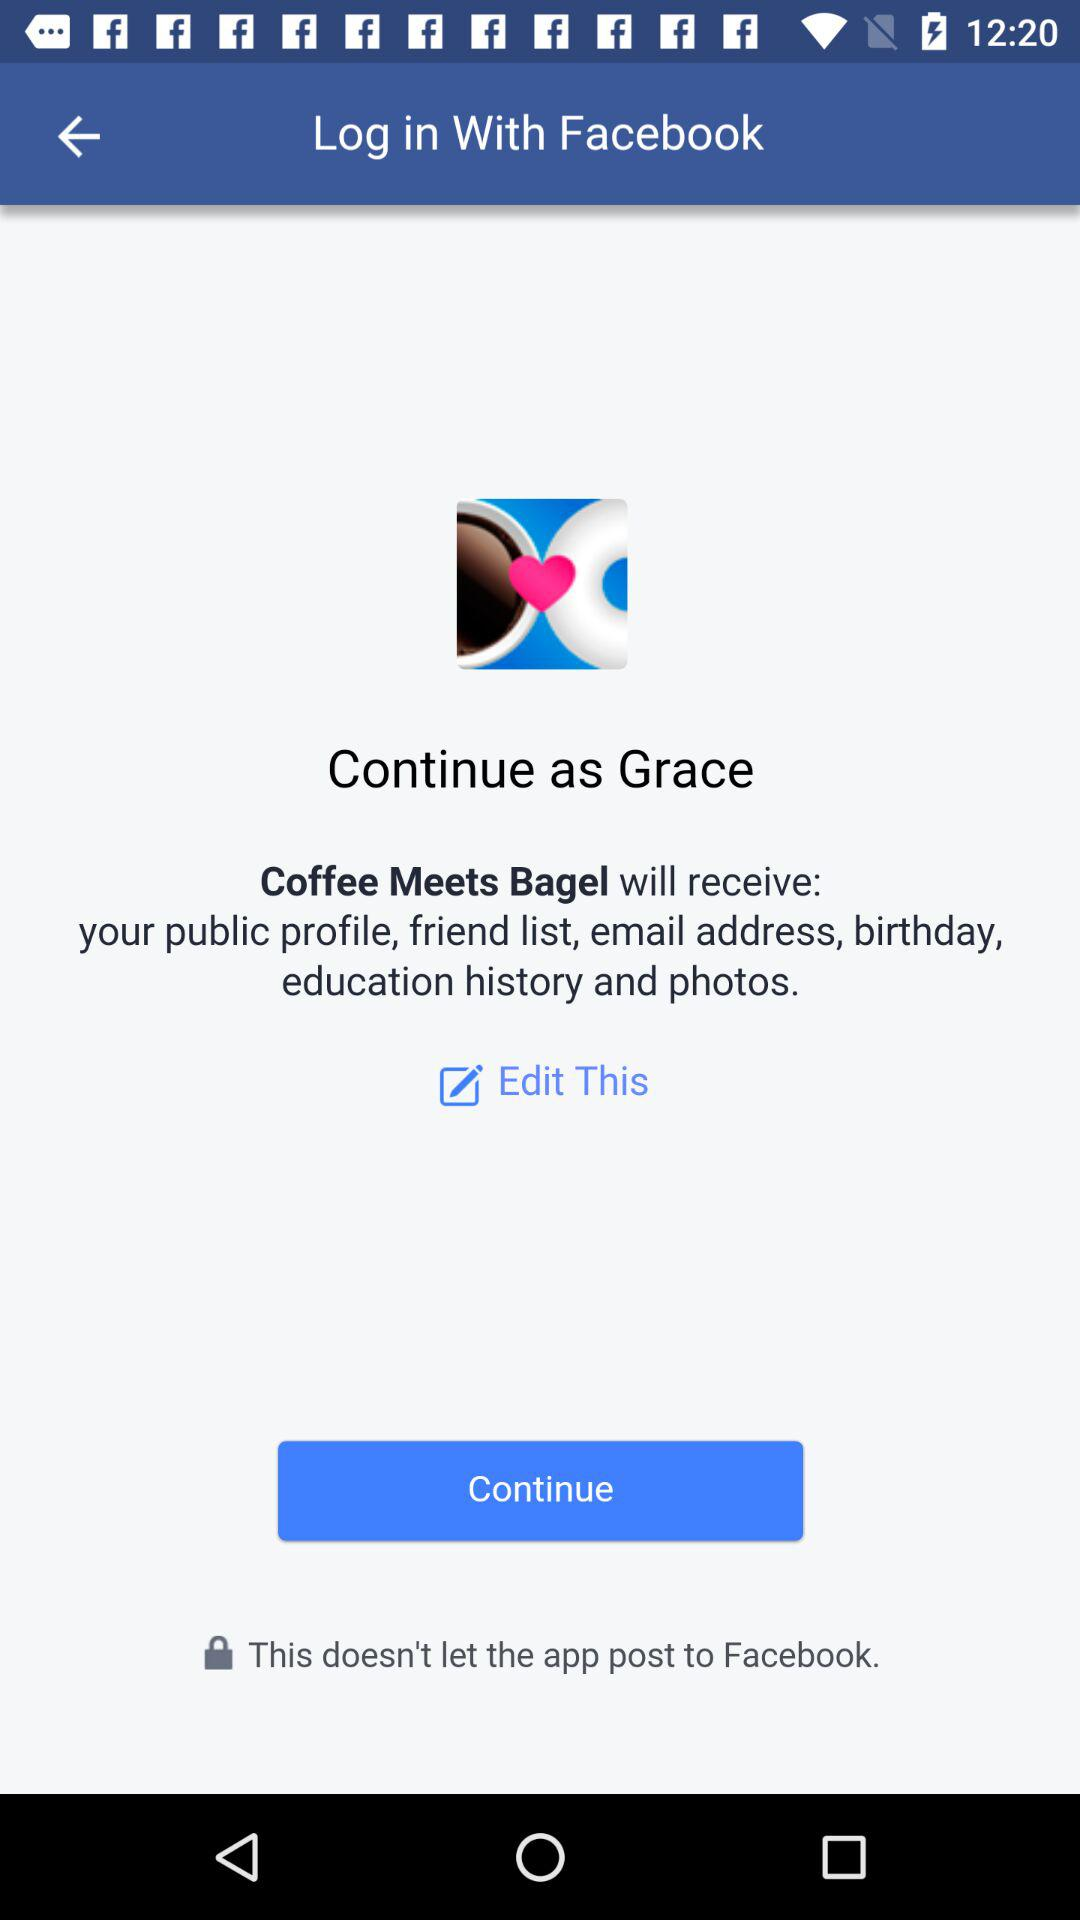Who developed the "Coffee Meets Bagel" app?
When the provided information is insufficient, respond with <no answer>. <no answer> 